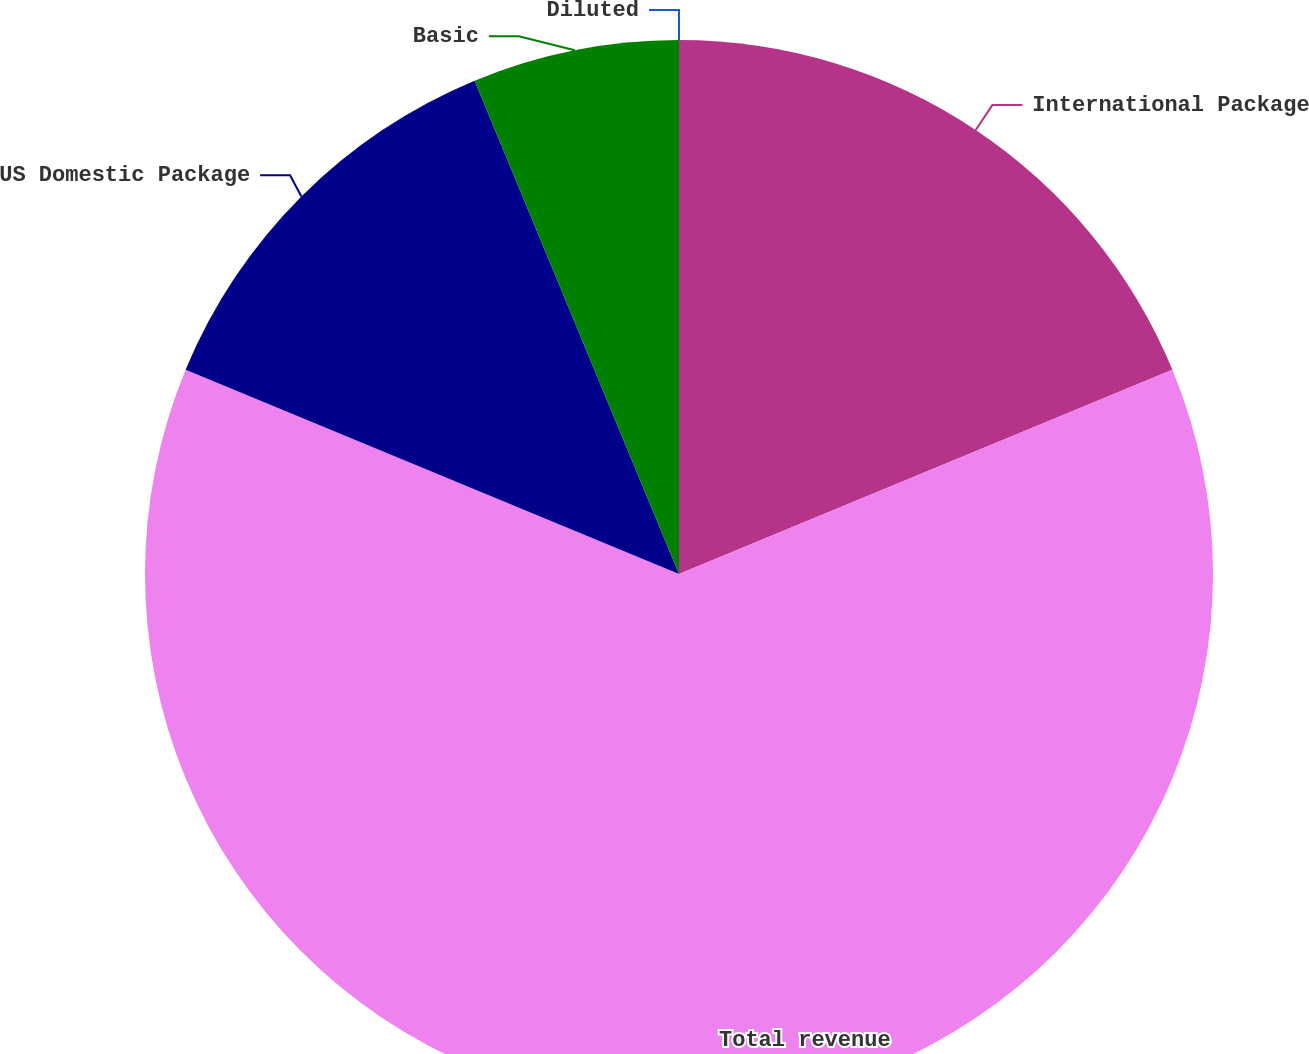<chart> <loc_0><loc_0><loc_500><loc_500><pie_chart><fcel>International Package<fcel>Total revenue<fcel>US Domestic Package<fcel>Basic<fcel>Diluted<nl><fcel>18.75%<fcel>62.49%<fcel>12.5%<fcel>6.25%<fcel>0.0%<nl></chart> 